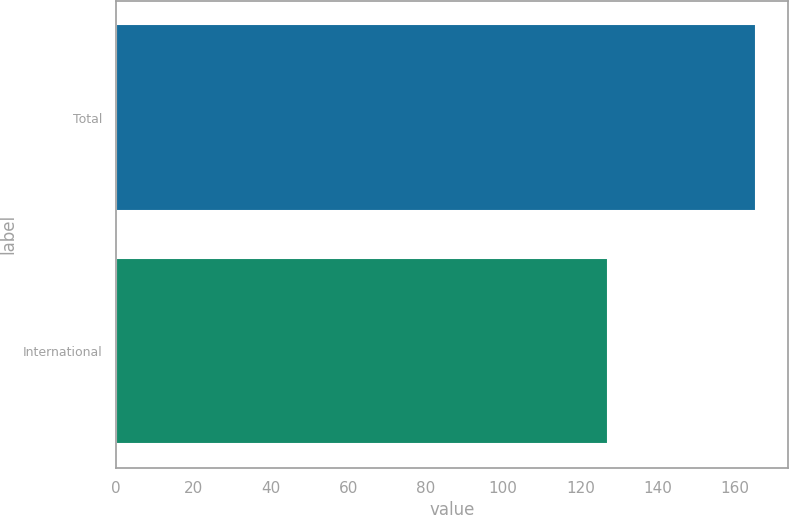<chart> <loc_0><loc_0><loc_500><loc_500><bar_chart><fcel>Total<fcel>International<nl><fcel>165.4<fcel>127.1<nl></chart> 